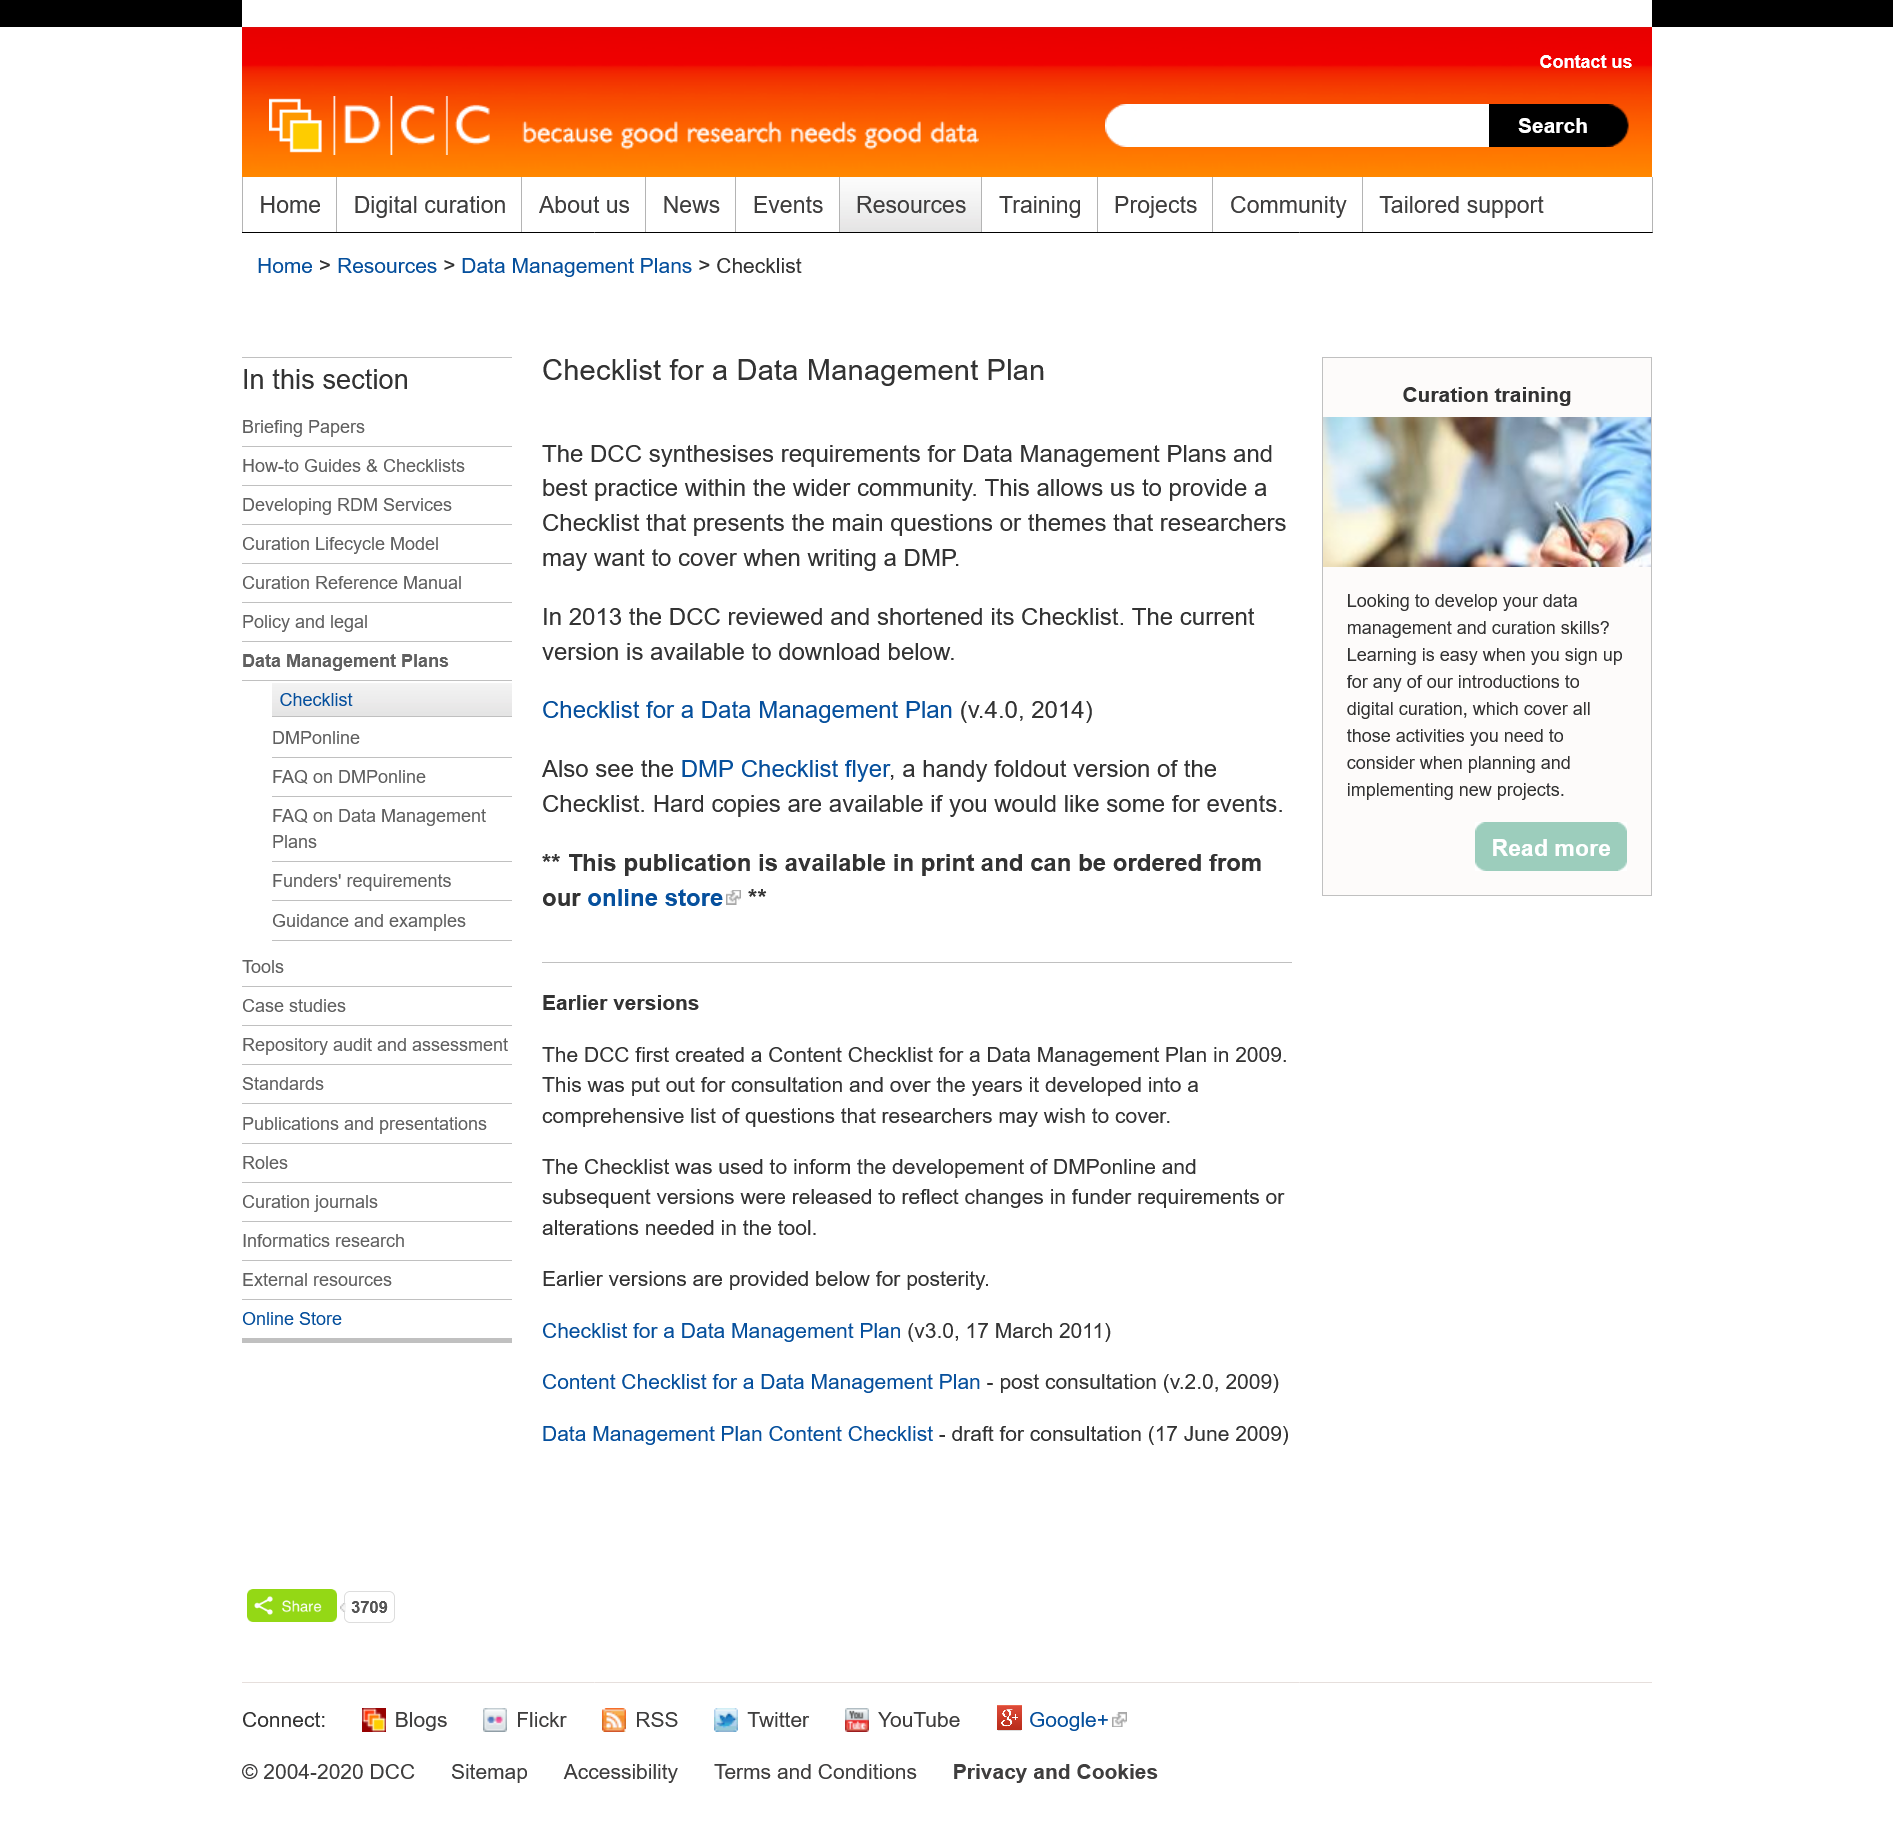Highlight a few significant elements in this photo. The DCC's Data Management Plan Checklist is intended for use by researchers. The DCC's Checklist for a Data Management Plan is available in both digital and print formats. Yes, the DCC have an online store. 